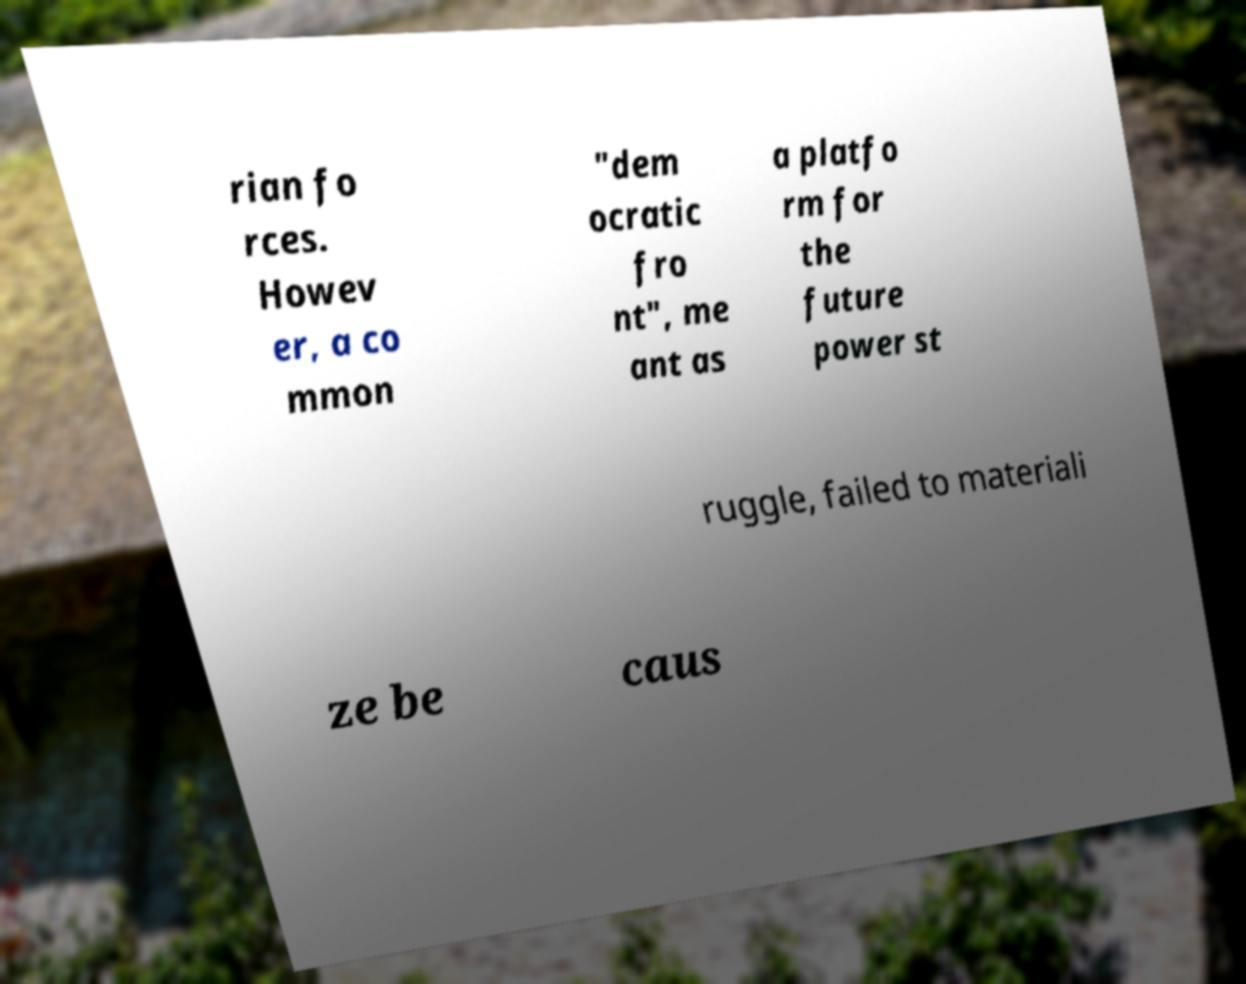Can you accurately transcribe the text from the provided image for me? rian fo rces. Howev er, a co mmon "dem ocratic fro nt", me ant as a platfo rm for the future power st ruggle, failed to materiali ze be caus 